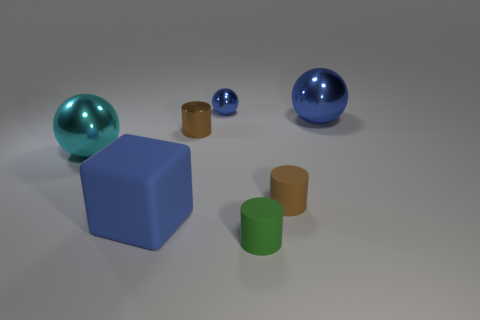What color is the thing that is behind the blue rubber cube and in front of the cyan metallic object?
Your answer should be compact. Brown. Are there more large objects that are to the left of the green object than tiny shiny things that are left of the cyan metallic object?
Your answer should be compact. Yes. There is a thing that is to the left of the blue matte cube; is its size the same as the small brown metal thing?
Make the answer very short. No. There is a tiny metallic thing that is behind the big metal ball on the right side of the blue matte object; what number of things are to the left of it?
Your answer should be very brief. 3. There is a blue thing that is both on the left side of the green object and behind the brown metallic cylinder; how big is it?
Offer a terse response. Small. How many other things are there of the same shape as the tiny green matte thing?
Keep it short and to the point. 2. There is a brown shiny cylinder; what number of brown matte cylinders are on the right side of it?
Ensure brevity in your answer.  1. Is the number of blue spheres in front of the small green matte thing less than the number of tiny cylinders that are in front of the metallic cylinder?
Your answer should be very brief. Yes. The brown object to the left of the tiny object that is behind the big shiny ball that is to the right of the cyan shiny thing is what shape?
Your answer should be compact. Cylinder. What is the shape of the large object that is behind the big blue rubber cube and left of the green thing?
Your answer should be very brief. Sphere. 